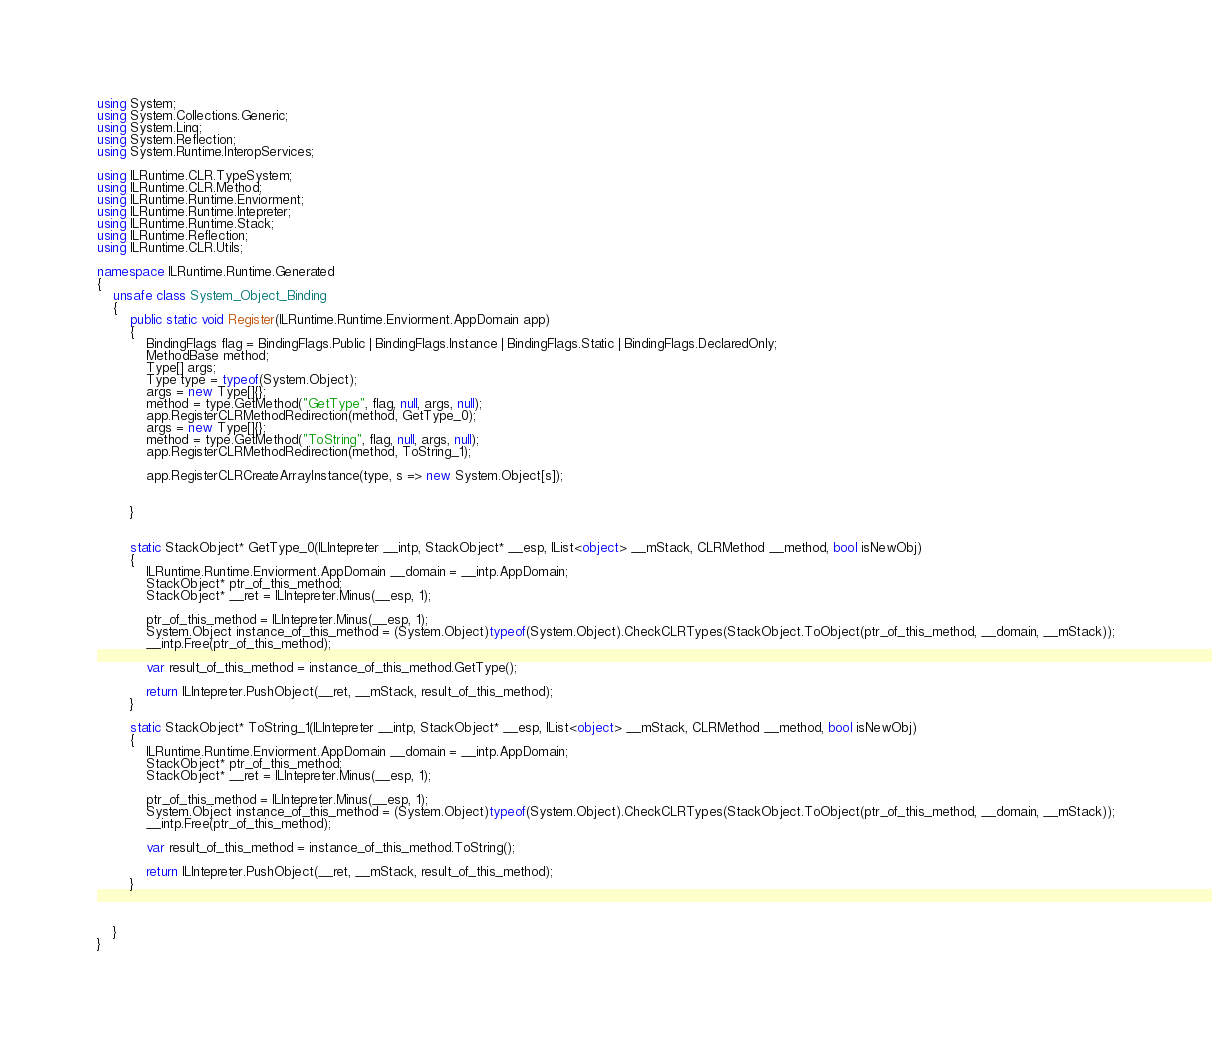<code> <loc_0><loc_0><loc_500><loc_500><_C#_>using System;
using System.Collections.Generic;
using System.Linq;
using System.Reflection;
using System.Runtime.InteropServices;

using ILRuntime.CLR.TypeSystem;
using ILRuntime.CLR.Method;
using ILRuntime.Runtime.Enviorment;
using ILRuntime.Runtime.Intepreter;
using ILRuntime.Runtime.Stack;
using ILRuntime.Reflection;
using ILRuntime.CLR.Utils;

namespace ILRuntime.Runtime.Generated
{
    unsafe class System_Object_Binding
    {
        public static void Register(ILRuntime.Runtime.Enviorment.AppDomain app)
        {
            BindingFlags flag = BindingFlags.Public | BindingFlags.Instance | BindingFlags.Static | BindingFlags.DeclaredOnly;
            MethodBase method;
            Type[] args;
            Type type = typeof(System.Object);
            args = new Type[]{};
            method = type.GetMethod("GetType", flag, null, args, null);
            app.RegisterCLRMethodRedirection(method, GetType_0);
            args = new Type[]{};
            method = type.GetMethod("ToString", flag, null, args, null);
            app.RegisterCLRMethodRedirection(method, ToString_1);

            app.RegisterCLRCreateArrayInstance(type, s => new System.Object[s]);


        }


        static StackObject* GetType_0(ILIntepreter __intp, StackObject* __esp, IList<object> __mStack, CLRMethod __method, bool isNewObj)
        {
            ILRuntime.Runtime.Enviorment.AppDomain __domain = __intp.AppDomain;
            StackObject* ptr_of_this_method;
            StackObject* __ret = ILIntepreter.Minus(__esp, 1);

            ptr_of_this_method = ILIntepreter.Minus(__esp, 1);
            System.Object instance_of_this_method = (System.Object)typeof(System.Object).CheckCLRTypes(StackObject.ToObject(ptr_of_this_method, __domain, __mStack));
            __intp.Free(ptr_of_this_method);

            var result_of_this_method = instance_of_this_method.GetType();

            return ILIntepreter.PushObject(__ret, __mStack, result_of_this_method);
        }

        static StackObject* ToString_1(ILIntepreter __intp, StackObject* __esp, IList<object> __mStack, CLRMethod __method, bool isNewObj)
        {
            ILRuntime.Runtime.Enviorment.AppDomain __domain = __intp.AppDomain;
            StackObject* ptr_of_this_method;
            StackObject* __ret = ILIntepreter.Minus(__esp, 1);

            ptr_of_this_method = ILIntepreter.Minus(__esp, 1);
            System.Object instance_of_this_method = (System.Object)typeof(System.Object).CheckCLRTypes(StackObject.ToObject(ptr_of_this_method, __domain, __mStack));
            __intp.Free(ptr_of_this_method);

            var result_of_this_method = instance_of_this_method.ToString();

            return ILIntepreter.PushObject(__ret, __mStack, result_of_this_method);
        }



    }
}
</code> 